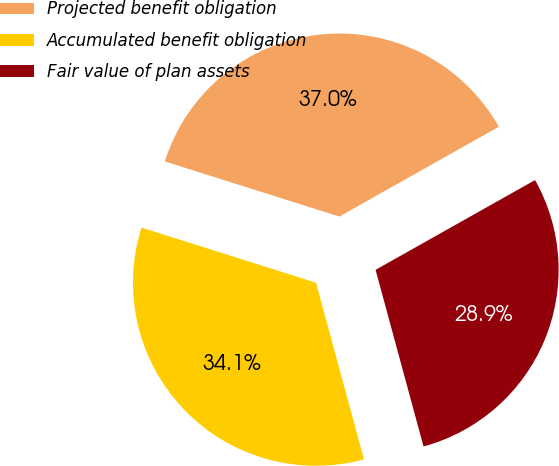Convert chart. <chart><loc_0><loc_0><loc_500><loc_500><pie_chart><fcel>Projected benefit obligation<fcel>Accumulated benefit obligation<fcel>Fair value of plan assets<nl><fcel>36.97%<fcel>34.09%<fcel>28.94%<nl></chart> 